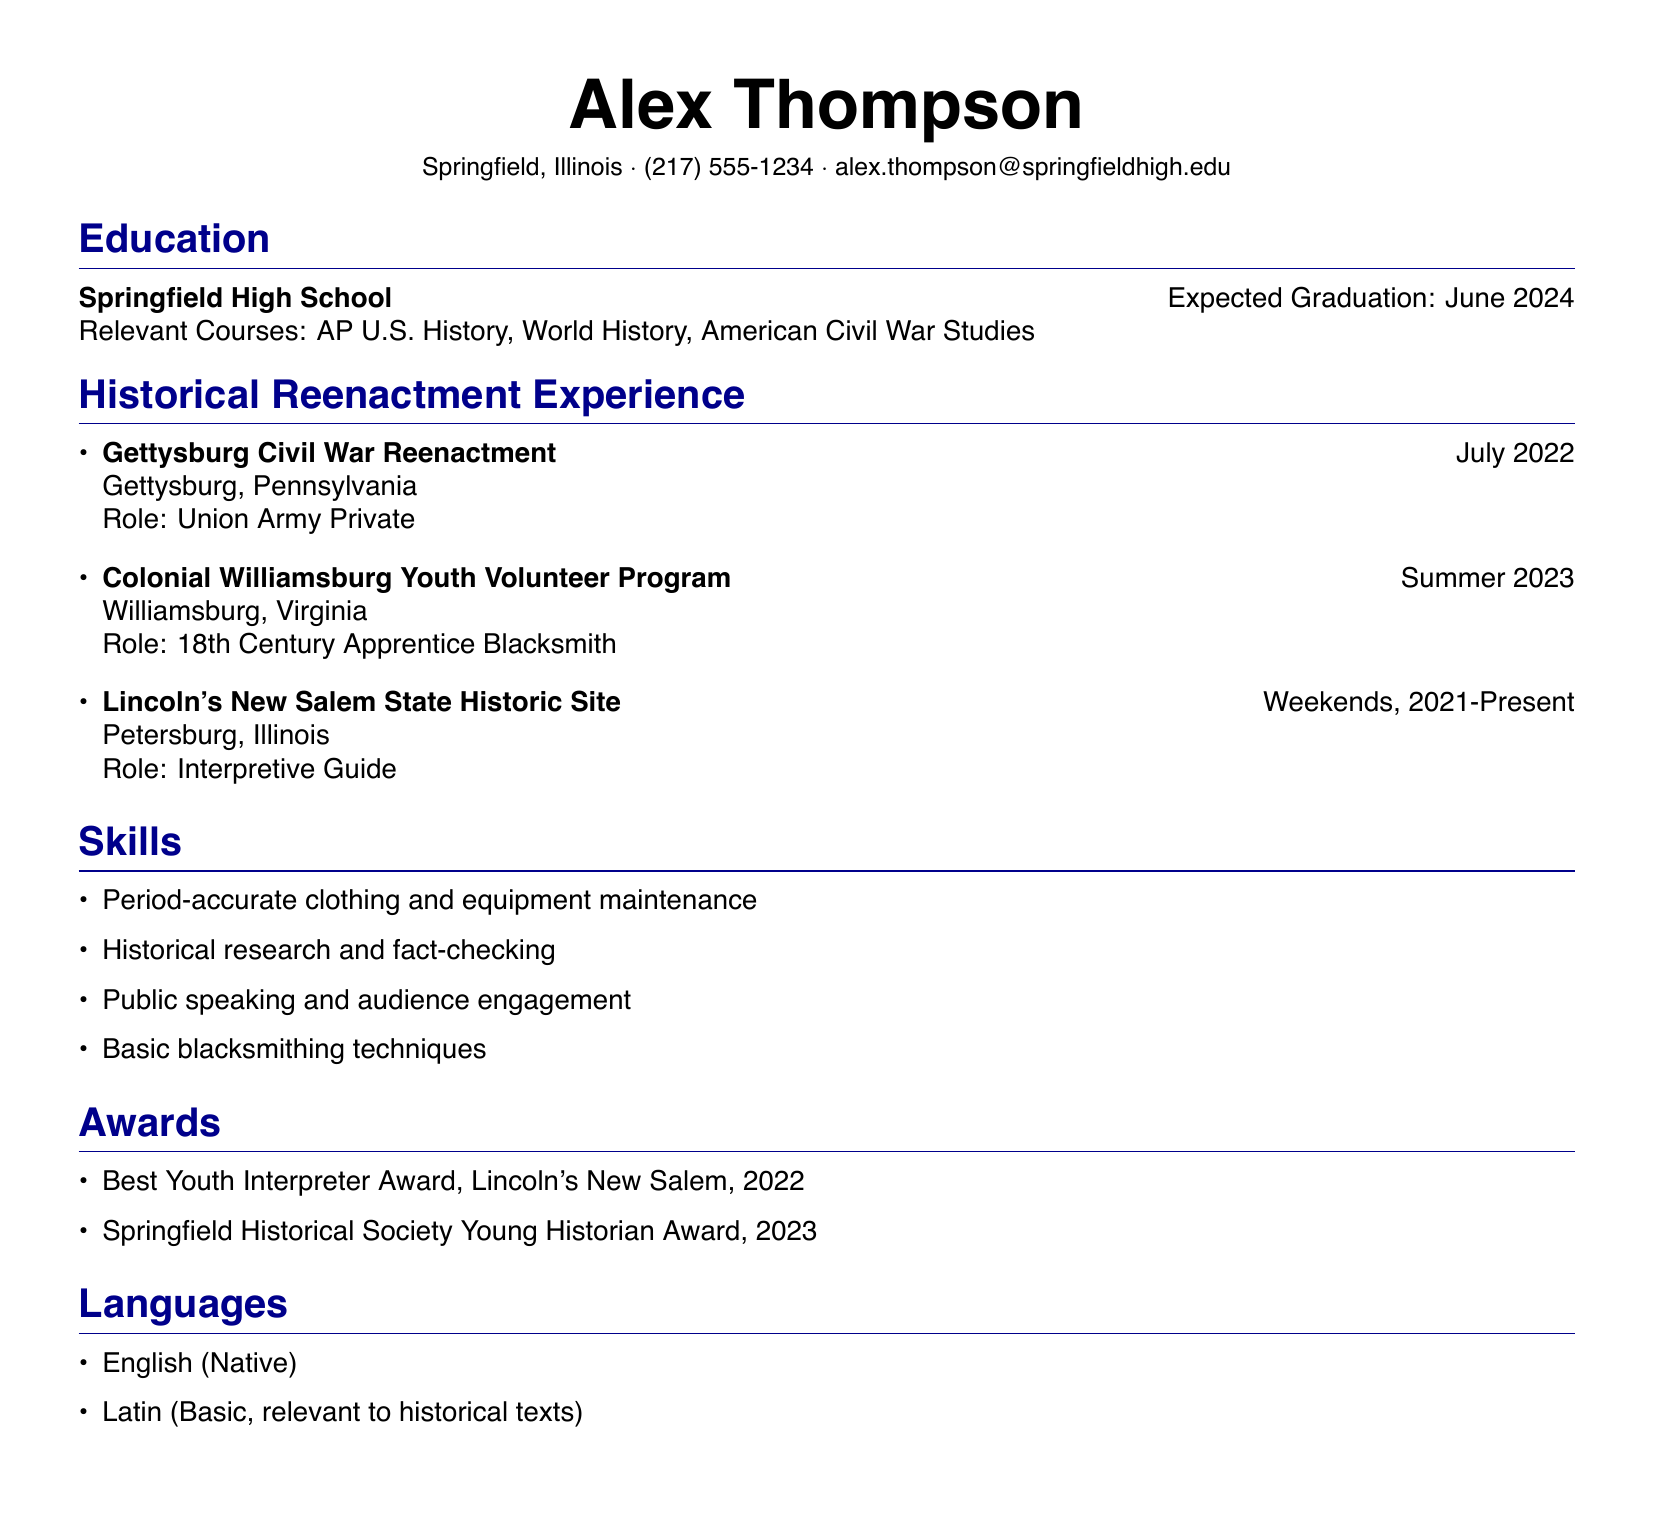What is Alex Thompson's role at the Gettysburg Civil War Reenactment? The document states that Alex's role was "Union Army Private" at the Gettysburg Civil War Reenactment.
Answer: Union Army Private In which city is the Lincoln's New Salem State Historic Site located? The document specifies that the Lincoln's New Salem State Historic Site is located in Petersburg, Illinois.
Answer: Petersburg, Illinois What award did Alex Thompson receive in 2022? The document lists "Best Youth Interpreter Award, Lincoln's New Salem, 2022" as an award Alex received in that year.
Answer: Best Youth Interpreter Award How long has Alex been an Interpretive Guide at Lincoln's New Salem? The document mentions Alex has been an Interpretive Guide "Weekends, 2021-Present", indicating he has been in that role for over two years.
Answer: Over two years What is one of the skills Alex Thompson possesses? The document includes "Historical research and fact-checking" as a skill Alex possesses.
Answer: Historical research and fact-checking What course related to his historical interests is Alex taking? The document lists "AP U.S. History" as a relevant course for Alex's historical interests.
Answer: AP U.S. History What type of historical event does Alex participate in during his weekends? The document states Alex participates in events at "Lincoln's New Salem State Historic Site" during weekends.
Answer: Lincoln's New Salem State Historic Site What language does Alex have basic knowledge of that is relevant to historical texts? The document states Alex has a basic knowledge of "Latin" relevant to historical texts.
Answer: Latin 